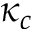<formula> <loc_0><loc_0><loc_500><loc_500>\kappa _ { c }</formula> 